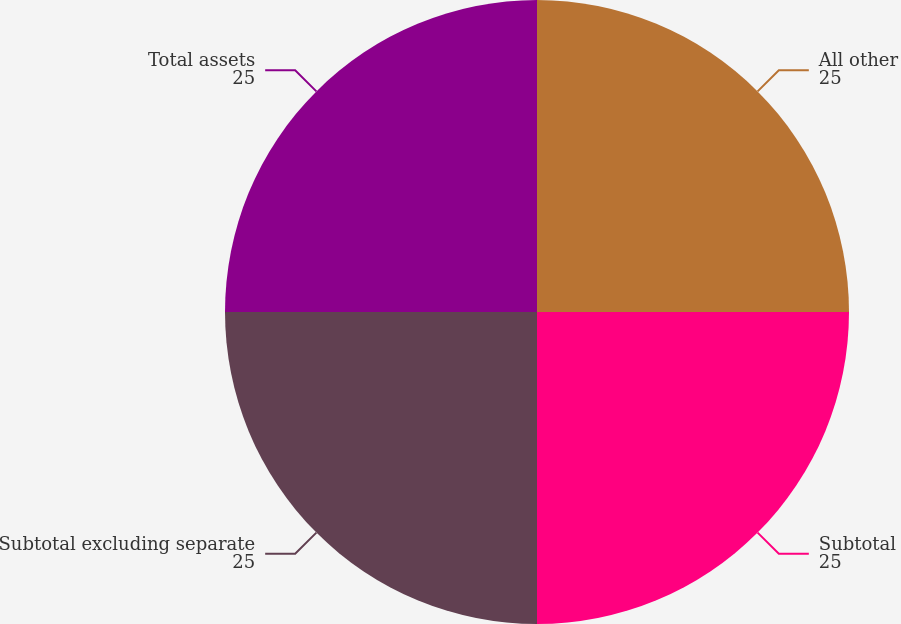Convert chart to OTSL. <chart><loc_0><loc_0><loc_500><loc_500><pie_chart><fcel>All other<fcel>Subtotal<fcel>Subtotal excluding separate<fcel>Total assets<nl><fcel>25.0%<fcel>25.0%<fcel>25.0%<fcel>25.0%<nl></chart> 